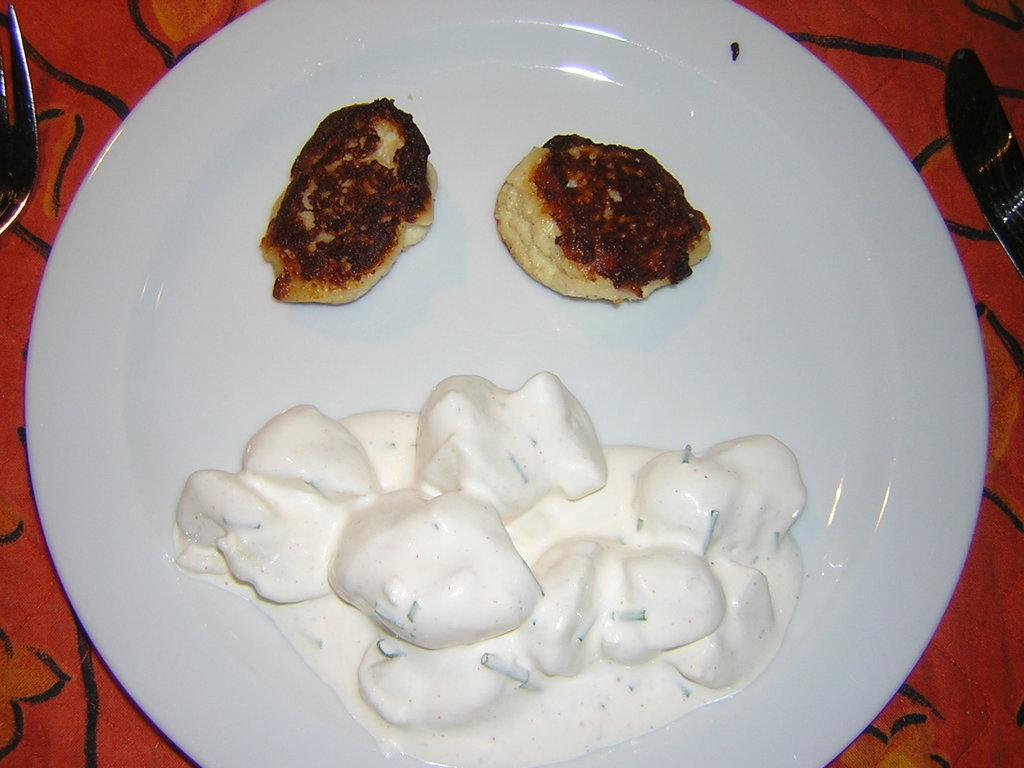What color is the plate in the image? The plate in the image is white. Where is the plate located? The plate is kept on a table. How many forks are on the table? There are two forks on the table. What else can be seen in the image besides the plate and forks? Food is visible in the image. What type of rake is being used to process the food in the image? There is no rake or food processing activity visible in the image. 